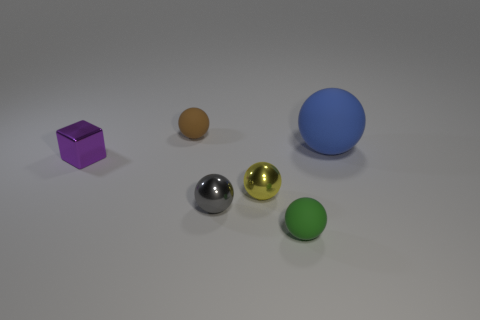How big is the matte thing in front of the small purple thing?
Your response must be concise. Small. Are there the same number of large blue things left of the purple cube and large rubber spheres?
Ensure brevity in your answer.  No. Are there any tiny yellow shiny things of the same shape as the small gray object?
Provide a short and direct response. Yes. There is a object that is both behind the purple metal cube and on the left side of the large matte ball; what shape is it?
Keep it short and to the point. Sphere. Do the small gray sphere and the purple object that is behind the small yellow metallic sphere have the same material?
Provide a succinct answer. Yes. Are there any gray balls behind the purple metal thing?
Give a very brief answer. No. What number of objects are big green metal balls or things behind the green matte sphere?
Give a very brief answer. 5. The tiny matte object that is right of the matte ball on the left side of the green thing is what color?
Your answer should be compact. Green. How many metal objects are either objects or purple things?
Your response must be concise. 3. The large matte object that is the same shape as the gray metal thing is what color?
Your answer should be compact. Blue. 